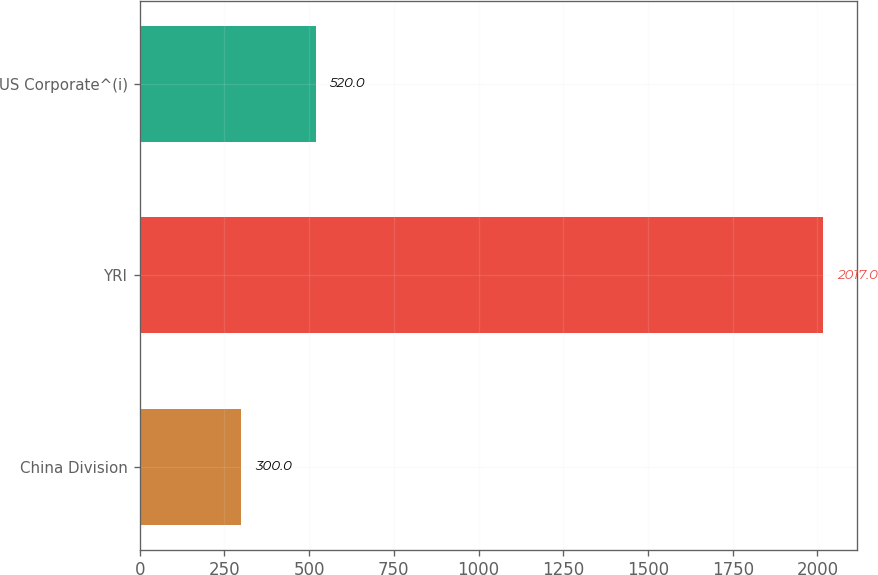Convert chart to OTSL. <chart><loc_0><loc_0><loc_500><loc_500><bar_chart><fcel>China Division<fcel>YRI<fcel>US Corporate^(i)<nl><fcel>300<fcel>2017<fcel>520<nl></chart> 